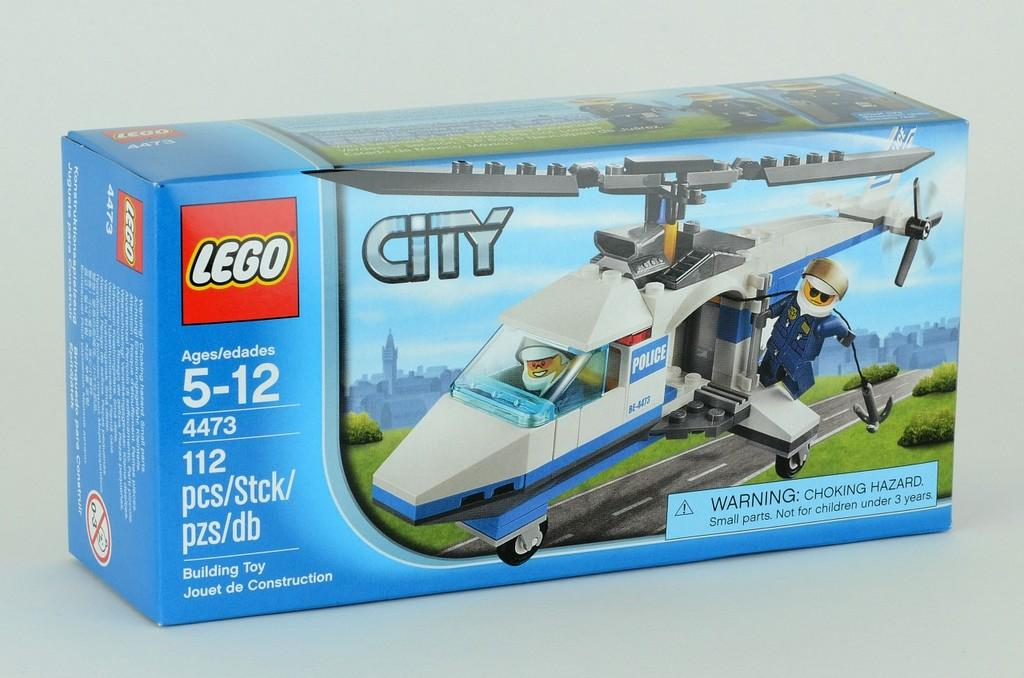<image>
Write a terse but informative summary of the picture. a box of city legos to build a helicopter for ages 5-12 